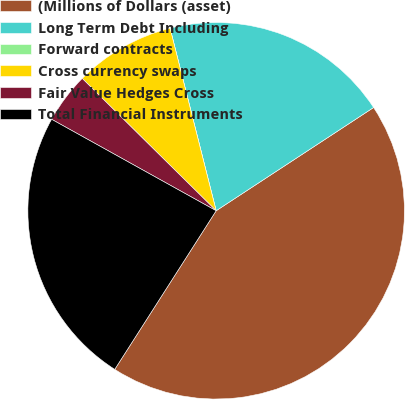Convert chart to OTSL. <chart><loc_0><loc_0><loc_500><loc_500><pie_chart><fcel>(Millions of Dollars (asset)<fcel>Long Term Debt Including<fcel>Forward contracts<fcel>Cross currency swaps<fcel>Fair Value Hedges Cross<fcel>Total Financial Instruments<nl><fcel>43.29%<fcel>19.7%<fcel>0.0%<fcel>8.66%<fcel>4.33%<fcel>24.02%<nl></chart> 